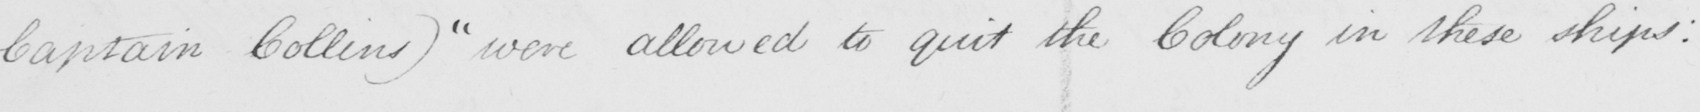Can you tell me what this handwritten text says? Captain Collins )   " were allowed to quit the Colony in these ships : 